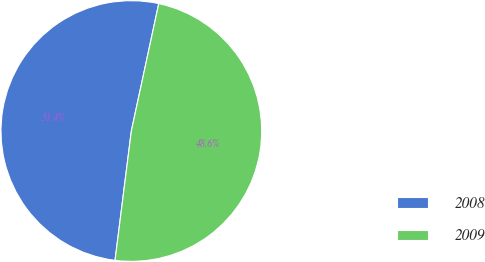Convert chart. <chart><loc_0><loc_0><loc_500><loc_500><pie_chart><fcel>2008<fcel>2009<nl><fcel>51.38%<fcel>48.62%<nl></chart> 